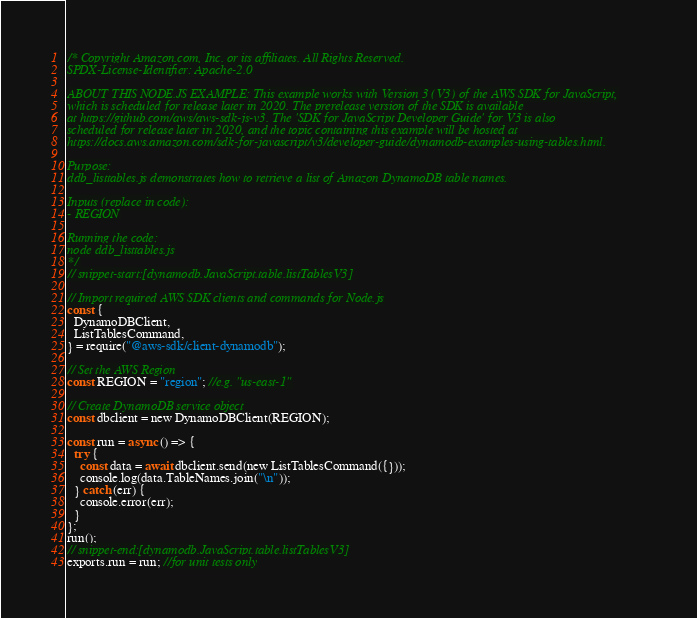<code> <loc_0><loc_0><loc_500><loc_500><_JavaScript_>/* Copyright Amazon.com, Inc. or its affiliates. All Rights Reserved.
SPDX-License-Identifier: Apache-2.0

ABOUT THIS NODE.JS EXAMPLE: This example works with Version 3 (V3) of the AWS SDK for JavaScript,
which is scheduled for release later in 2020. The prerelease version of the SDK is available
at https://github.com/aws/aws-sdk-js-v3. The 'SDK for JavaScript Developer Guide' for V3 is also
scheduled for release later in 2020, and the topic containing this example will be hosted at
https://docs.aws.amazon.com/sdk-for-javascript/v3/developer-guide/dynamodb-examples-using-tables.html.

Purpose:
ddb_listtables.js demonstrates how to retrieve a list of Amazon DynamoDB table names.

Inputs (replace in code):
- REGION

Running the code:
node ddb_listtables.js
*/
// snippet-start:[dynamodb.JavaScript.table.listTablesV3]

// Import required AWS SDK clients and commands for Node.js
const {
  DynamoDBClient,
  ListTablesCommand,
} = require("@aws-sdk/client-dynamodb");

// Set the AWS Region
const REGION = "region"; //e.g. "us-east-1"

// Create DynamoDB service object
const dbclient = new DynamoDBClient(REGION);

const run = async () => {
  try {
    const data = await dbclient.send(new ListTablesCommand({}));
    console.log(data.TableNames.join("\n"));
  } catch (err) {
    console.error(err);
  }
};
run();
// snippet-end:[dynamodb.JavaScript.table.listTablesV3]
exports.run = run; //for unit tests only
</code> 